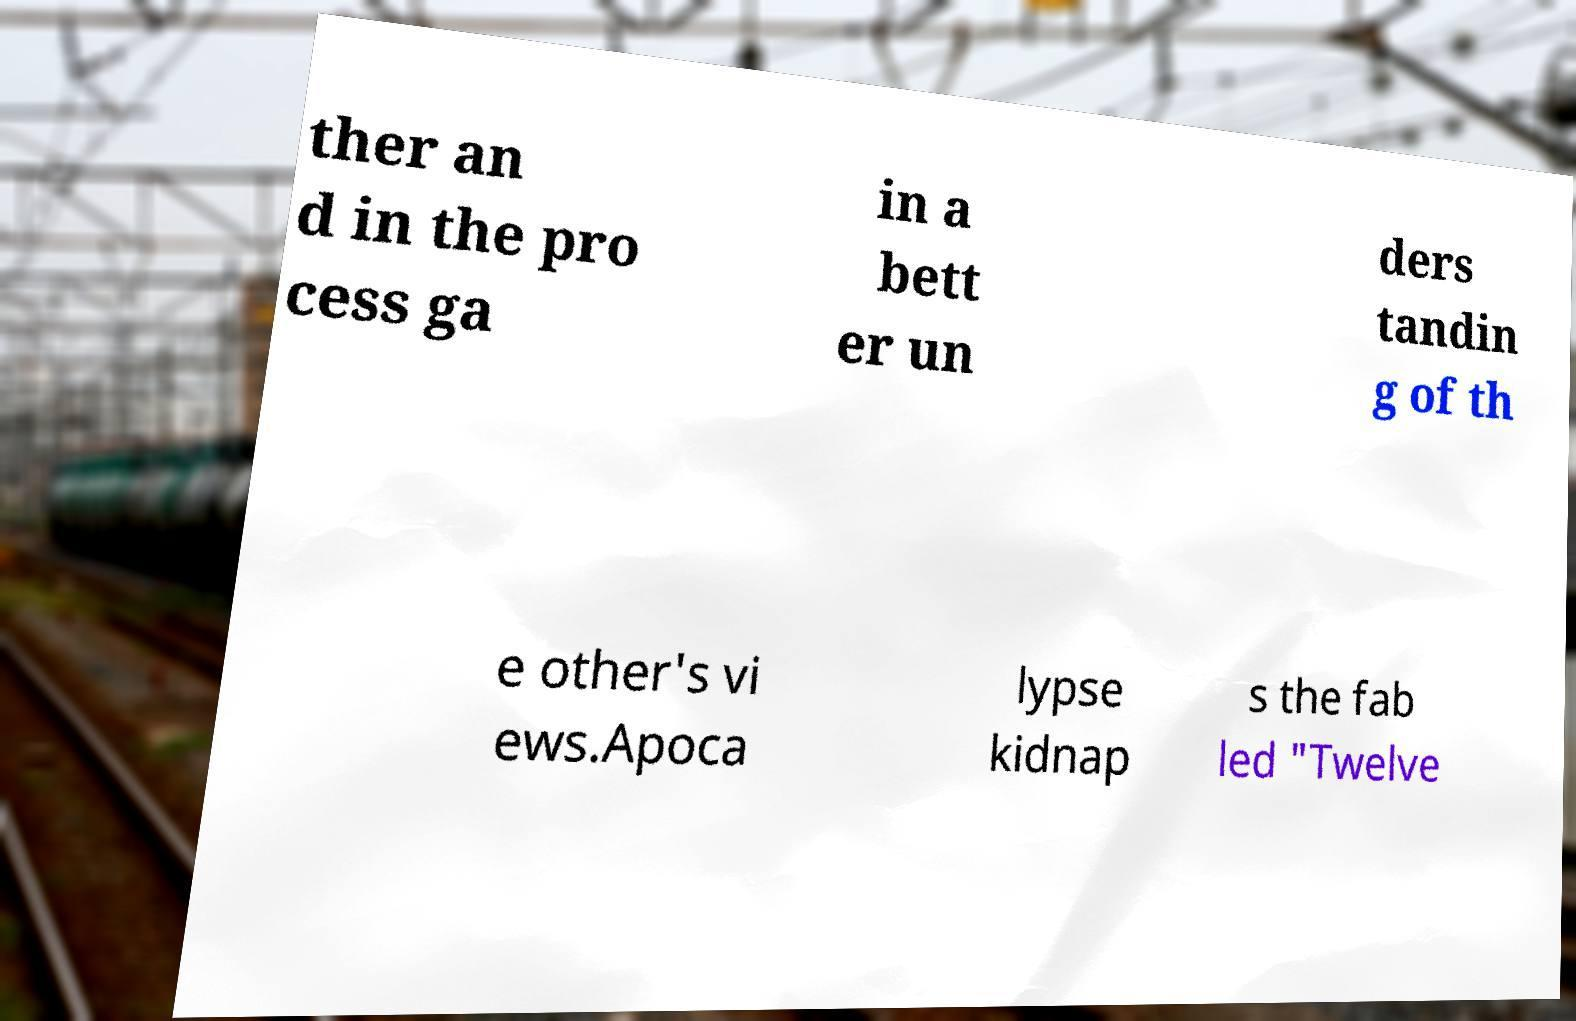What messages or text are displayed in this image? I need them in a readable, typed format. ther an d in the pro cess ga in a bett er un ders tandin g of th e other's vi ews.Apoca lypse kidnap s the fab led "Twelve 